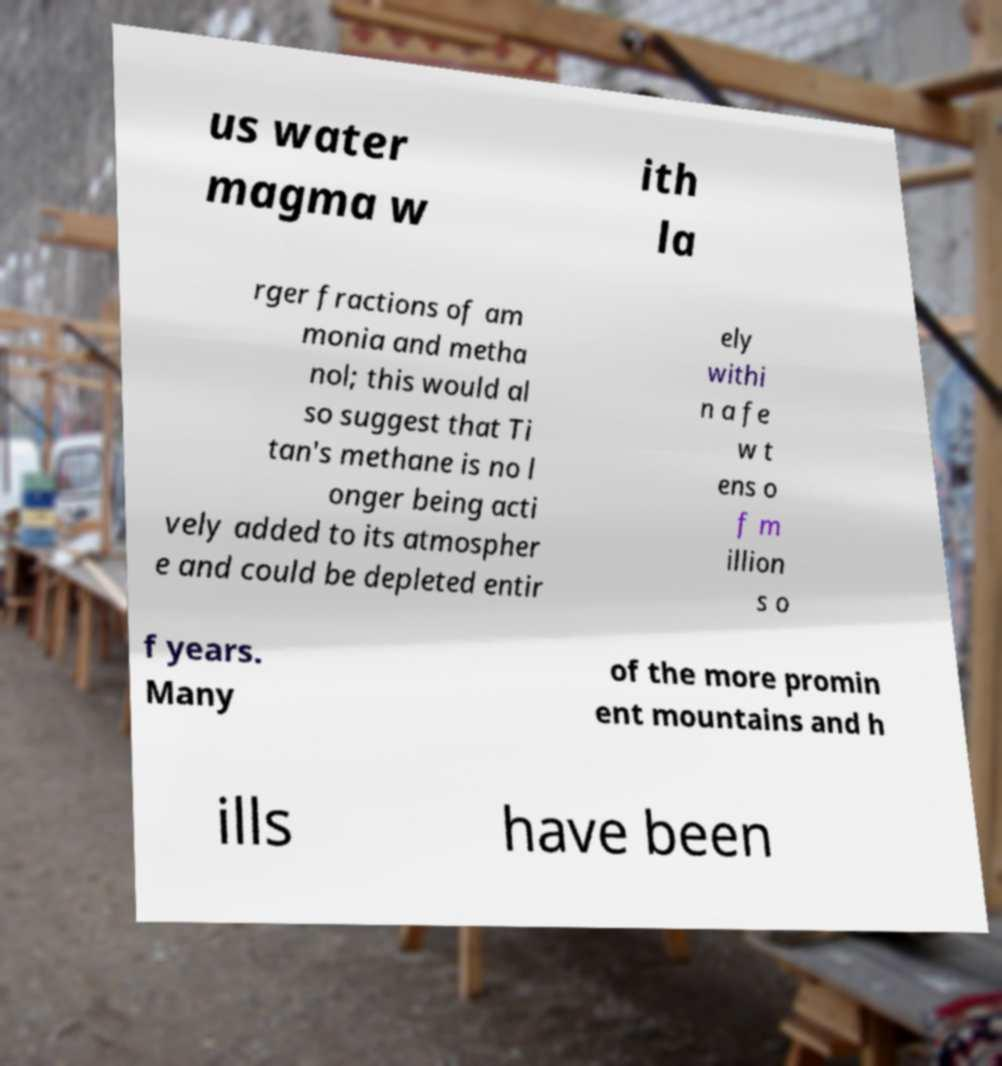Please read and relay the text visible in this image. What does it say? us water magma w ith la rger fractions of am monia and metha nol; this would al so suggest that Ti tan's methane is no l onger being acti vely added to its atmospher e and could be depleted entir ely withi n a fe w t ens o f m illion s o f years. Many of the more promin ent mountains and h ills have been 